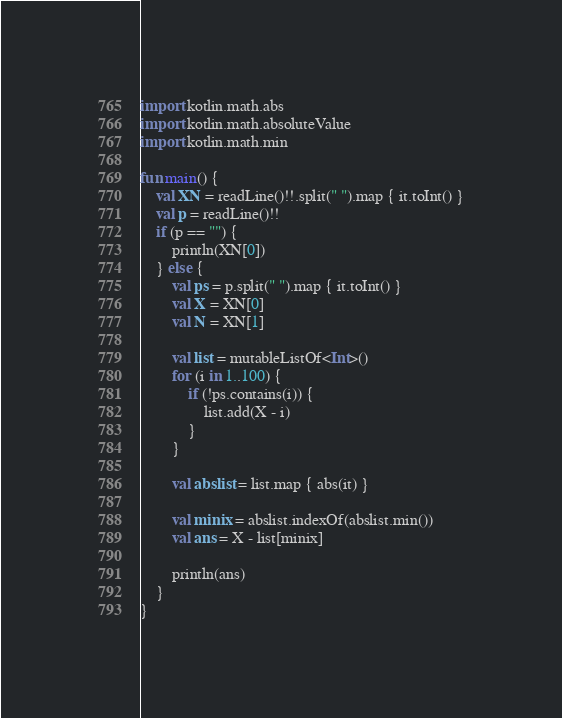<code> <loc_0><loc_0><loc_500><loc_500><_Kotlin_>import kotlin.math.abs
import kotlin.math.absoluteValue
import kotlin.math.min

fun main() {
    val XN = readLine()!!.split(" ").map { it.toInt() }
    val p = readLine()!!
    if (p == "") {
        println(XN[0])
    } else {
        val ps = p.split(" ").map { it.toInt() }
        val X = XN[0]
        val N = XN[1]

        val list = mutableListOf<Int>()
        for (i in 1..100) {
            if (!ps.contains(i)) {
                list.add(X - i)
            }
        }

        val abslist = list.map { abs(it) }

        val minix = abslist.indexOf(abslist.min())
        val ans = X - list[minix]

        println(ans)
    }
}</code> 